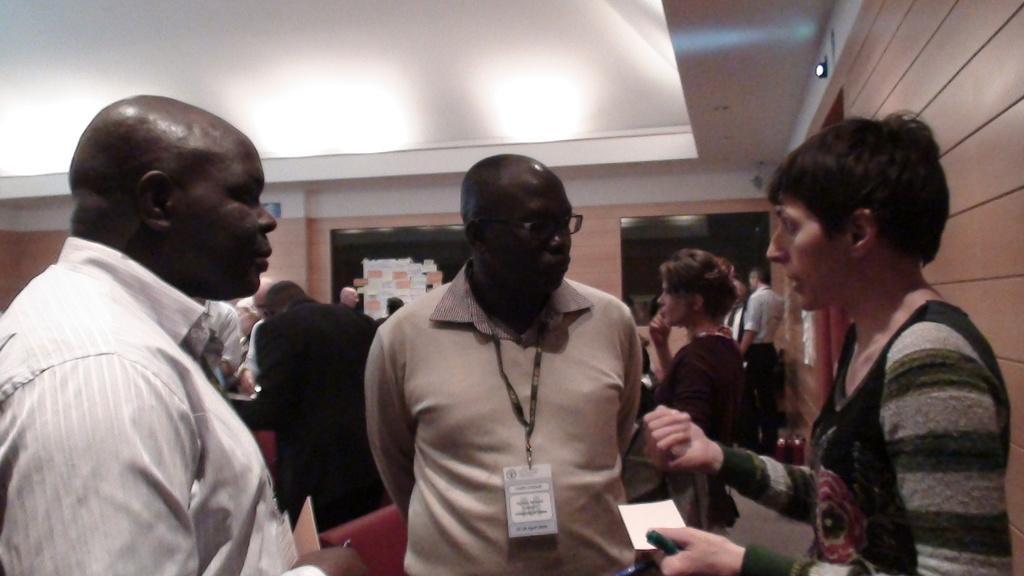Can you describe this image briefly? In this image I can see the group of people with different color dresses. I can see one with the specs and identification cards and two people are holding the papers. In the background I can see the papers to the wall. To the right there is a light. 